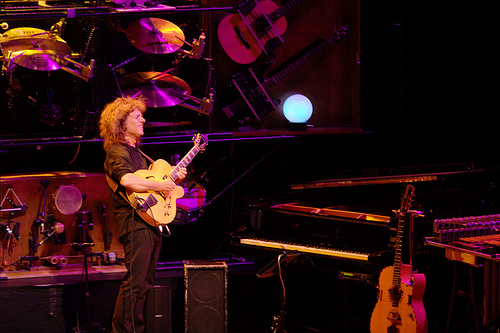<image>
Is the light in front of the person? No. The light is not in front of the person. The spatial positioning shows a different relationship between these objects. 